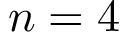Convert formula to latex. <formula><loc_0><loc_0><loc_500><loc_500>n = 4</formula> 